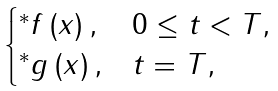Convert formula to latex. <formula><loc_0><loc_0><loc_500><loc_500>\begin{cases} ^ { \ast } f \left ( x \right ) , & 0 \leq t < T , \\ ^ { \ast } g \left ( x \right ) , & t = T , \end{cases}</formula> 